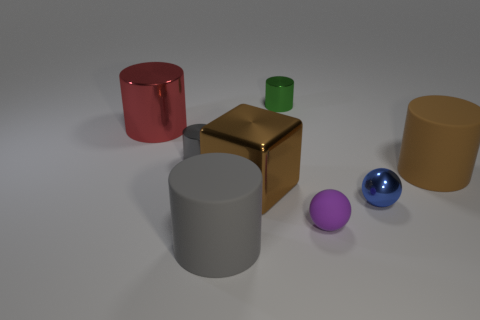Subtract all green cylinders. How many cylinders are left? 4 Subtract all small gray metal cylinders. How many cylinders are left? 4 Subtract 1 cylinders. How many cylinders are left? 4 Subtract all red cylinders. Subtract all blue blocks. How many cylinders are left? 4 Add 2 purple things. How many objects exist? 10 Subtract all spheres. How many objects are left? 6 Subtract all yellow metallic cylinders. Subtract all blue metal balls. How many objects are left? 7 Add 2 purple spheres. How many purple spheres are left? 3 Add 4 tiny shiny cylinders. How many tiny shiny cylinders exist? 6 Subtract 1 purple spheres. How many objects are left? 7 